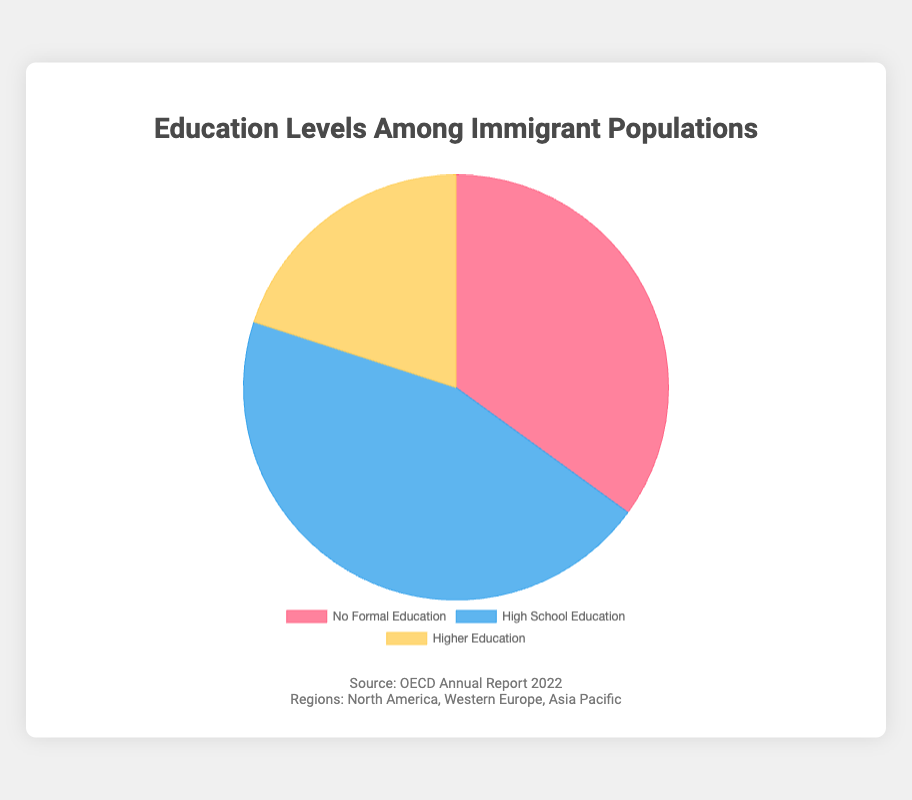What percentage of the immigrant population has no formal education? The pie chart shows that the segment for 'No Formal Education' is 35%.
Answer: 35% Which education level has the highest representation among the immigrant population? The pie chart indicates that 'High School Education' has the largest segment at 45%.
Answer: High School Education What is the combined percentage of immigrants with some form of education (either high school or higher education)? Adding the percentages for 'High School Education' (45%) and 'Higher Education' (20%) results in 65%.
Answer: 65% Which color represents the group with higher education? The legend and visual information show that the 'Higher Education' segment is colored yellow.
Answer: Yellow What is the ratio of immigrants with no formal education to those with higher education? The percentage for 'No Formal Education' is 35%, and 'Higher Education' is 20%. The ratio is 35:20, which simplifies to 7:4.
Answer: 7:4 How much larger is the high school educated segment compared to the higher educated segment? The 'High School Education' segment is 45%, and the 'Higher Education' segment is 20%. The difference is 45% - 20% = 25%.
Answer: 25% Identify the segment that has about twice the proportion compared to the 'Higher Education' segment. The 'Higher Education' segment is 20%. Doubling this gives 40%. 'High School Education' is 45%, which is closest to twice the proportion of 'Higher Education'.
Answer: High School Education Considering the regions listed (North America, Western Europe, Asia Pacific), which region could potentially have the highest impact on the distribution of education levels? Given these regions are diverse and each could have varying impacts, one could infer Western Europe due to historical migration policies favoring skilled labor, but further contextual information is necessary.
Answer: Western Europe (requires contextual inference) Which education level segment is colored blue? The legend and visual information indicate that the 'High School Education' segment is colored blue.
Answer: High School Education What fraction of the immigrant population has no formal education and higher education combined? Adding the percentages for 'No Formal Education' (35%) and 'Higher Education' (20%) gives 55%. Therefore, the fraction is 55%.
Answer: 55% 